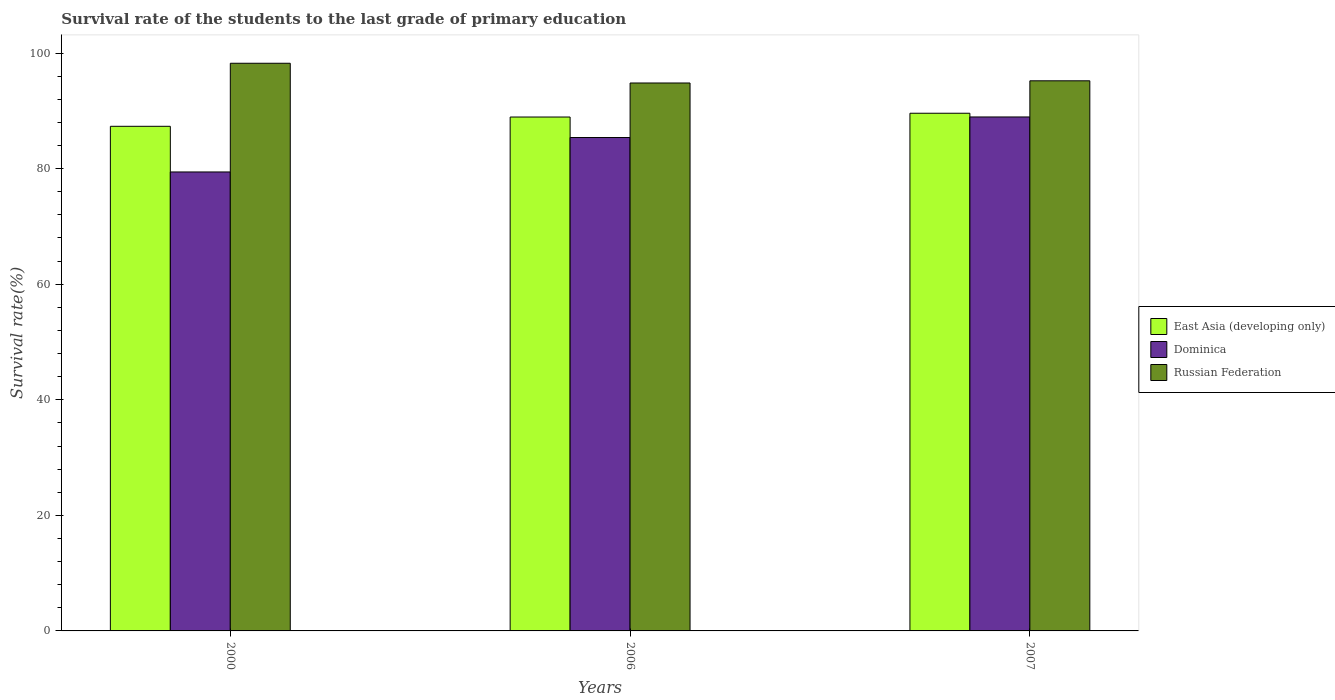How many groups of bars are there?
Provide a short and direct response. 3. Are the number of bars on each tick of the X-axis equal?
Offer a very short reply. Yes. What is the label of the 3rd group of bars from the left?
Offer a terse response. 2007. What is the survival rate of the students in East Asia (developing only) in 2000?
Make the answer very short. 87.33. Across all years, what is the maximum survival rate of the students in Russian Federation?
Offer a terse response. 98.24. Across all years, what is the minimum survival rate of the students in East Asia (developing only)?
Your answer should be very brief. 87.33. In which year was the survival rate of the students in Dominica maximum?
Make the answer very short. 2007. What is the total survival rate of the students in East Asia (developing only) in the graph?
Keep it short and to the point. 265.86. What is the difference between the survival rate of the students in Dominica in 2000 and that in 2007?
Your response must be concise. -9.52. What is the difference between the survival rate of the students in Russian Federation in 2007 and the survival rate of the students in Dominica in 2000?
Make the answer very short. 15.77. What is the average survival rate of the students in Russian Federation per year?
Ensure brevity in your answer.  96.09. In the year 2000, what is the difference between the survival rate of the students in Dominica and survival rate of the students in Russian Federation?
Your response must be concise. -18.81. In how many years, is the survival rate of the students in East Asia (developing only) greater than 12 %?
Make the answer very short. 3. What is the ratio of the survival rate of the students in East Asia (developing only) in 2000 to that in 2006?
Offer a terse response. 0.98. Is the difference between the survival rate of the students in Dominica in 2000 and 2006 greater than the difference between the survival rate of the students in Russian Federation in 2000 and 2006?
Keep it short and to the point. No. What is the difference between the highest and the second highest survival rate of the students in Russian Federation?
Your answer should be very brief. 3.04. What is the difference between the highest and the lowest survival rate of the students in Dominica?
Your response must be concise. 9.52. Is the sum of the survival rate of the students in Russian Federation in 2000 and 2007 greater than the maximum survival rate of the students in East Asia (developing only) across all years?
Provide a succinct answer. Yes. What does the 3rd bar from the left in 2006 represents?
Give a very brief answer. Russian Federation. What does the 3rd bar from the right in 2007 represents?
Your answer should be very brief. East Asia (developing only). How many bars are there?
Provide a short and direct response. 9. How many years are there in the graph?
Keep it short and to the point. 3. What is the difference between two consecutive major ticks on the Y-axis?
Provide a succinct answer. 20. Does the graph contain any zero values?
Ensure brevity in your answer.  No. Does the graph contain grids?
Provide a succinct answer. No. Where does the legend appear in the graph?
Provide a succinct answer. Center right. How many legend labels are there?
Give a very brief answer. 3. What is the title of the graph?
Your response must be concise. Survival rate of the students to the last grade of primary education. What is the label or title of the Y-axis?
Provide a short and direct response. Survival rate(%). What is the Survival rate(%) in East Asia (developing only) in 2000?
Your answer should be very brief. 87.33. What is the Survival rate(%) of Dominica in 2000?
Provide a succinct answer. 79.43. What is the Survival rate(%) of Russian Federation in 2000?
Your response must be concise. 98.24. What is the Survival rate(%) in East Asia (developing only) in 2006?
Provide a short and direct response. 88.94. What is the Survival rate(%) in Dominica in 2006?
Keep it short and to the point. 85.39. What is the Survival rate(%) of Russian Federation in 2006?
Your answer should be compact. 94.82. What is the Survival rate(%) in East Asia (developing only) in 2007?
Provide a short and direct response. 89.59. What is the Survival rate(%) of Dominica in 2007?
Ensure brevity in your answer.  88.94. What is the Survival rate(%) in Russian Federation in 2007?
Keep it short and to the point. 95.2. Across all years, what is the maximum Survival rate(%) of East Asia (developing only)?
Offer a very short reply. 89.59. Across all years, what is the maximum Survival rate(%) of Dominica?
Your answer should be compact. 88.94. Across all years, what is the maximum Survival rate(%) of Russian Federation?
Ensure brevity in your answer.  98.24. Across all years, what is the minimum Survival rate(%) of East Asia (developing only)?
Make the answer very short. 87.33. Across all years, what is the minimum Survival rate(%) in Dominica?
Ensure brevity in your answer.  79.43. Across all years, what is the minimum Survival rate(%) in Russian Federation?
Give a very brief answer. 94.82. What is the total Survival rate(%) in East Asia (developing only) in the graph?
Ensure brevity in your answer.  265.86. What is the total Survival rate(%) of Dominica in the graph?
Your answer should be compact. 253.76. What is the total Survival rate(%) of Russian Federation in the graph?
Offer a very short reply. 288.26. What is the difference between the Survival rate(%) of East Asia (developing only) in 2000 and that in 2006?
Offer a very short reply. -1.61. What is the difference between the Survival rate(%) in Dominica in 2000 and that in 2006?
Your answer should be very brief. -5.96. What is the difference between the Survival rate(%) of Russian Federation in 2000 and that in 2006?
Give a very brief answer. 3.42. What is the difference between the Survival rate(%) of East Asia (developing only) in 2000 and that in 2007?
Your response must be concise. -2.26. What is the difference between the Survival rate(%) of Dominica in 2000 and that in 2007?
Make the answer very short. -9.52. What is the difference between the Survival rate(%) in Russian Federation in 2000 and that in 2007?
Make the answer very short. 3.04. What is the difference between the Survival rate(%) of East Asia (developing only) in 2006 and that in 2007?
Give a very brief answer. -0.65. What is the difference between the Survival rate(%) in Dominica in 2006 and that in 2007?
Your response must be concise. -3.56. What is the difference between the Survival rate(%) in Russian Federation in 2006 and that in 2007?
Make the answer very short. -0.38. What is the difference between the Survival rate(%) of East Asia (developing only) in 2000 and the Survival rate(%) of Dominica in 2006?
Provide a short and direct response. 1.94. What is the difference between the Survival rate(%) of East Asia (developing only) in 2000 and the Survival rate(%) of Russian Federation in 2006?
Make the answer very short. -7.49. What is the difference between the Survival rate(%) in Dominica in 2000 and the Survival rate(%) in Russian Federation in 2006?
Your response must be concise. -15.4. What is the difference between the Survival rate(%) in East Asia (developing only) in 2000 and the Survival rate(%) in Dominica in 2007?
Offer a very short reply. -1.62. What is the difference between the Survival rate(%) in East Asia (developing only) in 2000 and the Survival rate(%) in Russian Federation in 2007?
Offer a terse response. -7.87. What is the difference between the Survival rate(%) in Dominica in 2000 and the Survival rate(%) in Russian Federation in 2007?
Keep it short and to the point. -15.77. What is the difference between the Survival rate(%) in East Asia (developing only) in 2006 and the Survival rate(%) in Dominica in 2007?
Give a very brief answer. -0.01. What is the difference between the Survival rate(%) of East Asia (developing only) in 2006 and the Survival rate(%) of Russian Federation in 2007?
Ensure brevity in your answer.  -6.27. What is the difference between the Survival rate(%) in Dominica in 2006 and the Survival rate(%) in Russian Federation in 2007?
Ensure brevity in your answer.  -9.81. What is the average Survival rate(%) of East Asia (developing only) per year?
Your response must be concise. 88.62. What is the average Survival rate(%) in Dominica per year?
Offer a terse response. 84.59. What is the average Survival rate(%) of Russian Federation per year?
Keep it short and to the point. 96.09. In the year 2000, what is the difference between the Survival rate(%) in East Asia (developing only) and Survival rate(%) in Dominica?
Ensure brevity in your answer.  7.9. In the year 2000, what is the difference between the Survival rate(%) of East Asia (developing only) and Survival rate(%) of Russian Federation?
Your response must be concise. -10.91. In the year 2000, what is the difference between the Survival rate(%) in Dominica and Survival rate(%) in Russian Federation?
Provide a succinct answer. -18.81. In the year 2006, what is the difference between the Survival rate(%) in East Asia (developing only) and Survival rate(%) in Dominica?
Your response must be concise. 3.55. In the year 2006, what is the difference between the Survival rate(%) in East Asia (developing only) and Survival rate(%) in Russian Federation?
Keep it short and to the point. -5.89. In the year 2006, what is the difference between the Survival rate(%) of Dominica and Survival rate(%) of Russian Federation?
Your answer should be very brief. -9.44. In the year 2007, what is the difference between the Survival rate(%) in East Asia (developing only) and Survival rate(%) in Dominica?
Offer a terse response. 0.65. In the year 2007, what is the difference between the Survival rate(%) in East Asia (developing only) and Survival rate(%) in Russian Federation?
Your response must be concise. -5.61. In the year 2007, what is the difference between the Survival rate(%) of Dominica and Survival rate(%) of Russian Federation?
Your answer should be very brief. -6.26. What is the ratio of the Survival rate(%) of East Asia (developing only) in 2000 to that in 2006?
Provide a succinct answer. 0.98. What is the ratio of the Survival rate(%) in Dominica in 2000 to that in 2006?
Give a very brief answer. 0.93. What is the ratio of the Survival rate(%) in Russian Federation in 2000 to that in 2006?
Make the answer very short. 1.04. What is the ratio of the Survival rate(%) of East Asia (developing only) in 2000 to that in 2007?
Give a very brief answer. 0.97. What is the ratio of the Survival rate(%) in Dominica in 2000 to that in 2007?
Provide a short and direct response. 0.89. What is the ratio of the Survival rate(%) in Russian Federation in 2000 to that in 2007?
Ensure brevity in your answer.  1.03. What is the difference between the highest and the second highest Survival rate(%) in East Asia (developing only)?
Ensure brevity in your answer.  0.65. What is the difference between the highest and the second highest Survival rate(%) of Dominica?
Give a very brief answer. 3.56. What is the difference between the highest and the second highest Survival rate(%) of Russian Federation?
Ensure brevity in your answer.  3.04. What is the difference between the highest and the lowest Survival rate(%) of East Asia (developing only)?
Your answer should be compact. 2.26. What is the difference between the highest and the lowest Survival rate(%) in Dominica?
Ensure brevity in your answer.  9.52. What is the difference between the highest and the lowest Survival rate(%) in Russian Federation?
Offer a terse response. 3.42. 